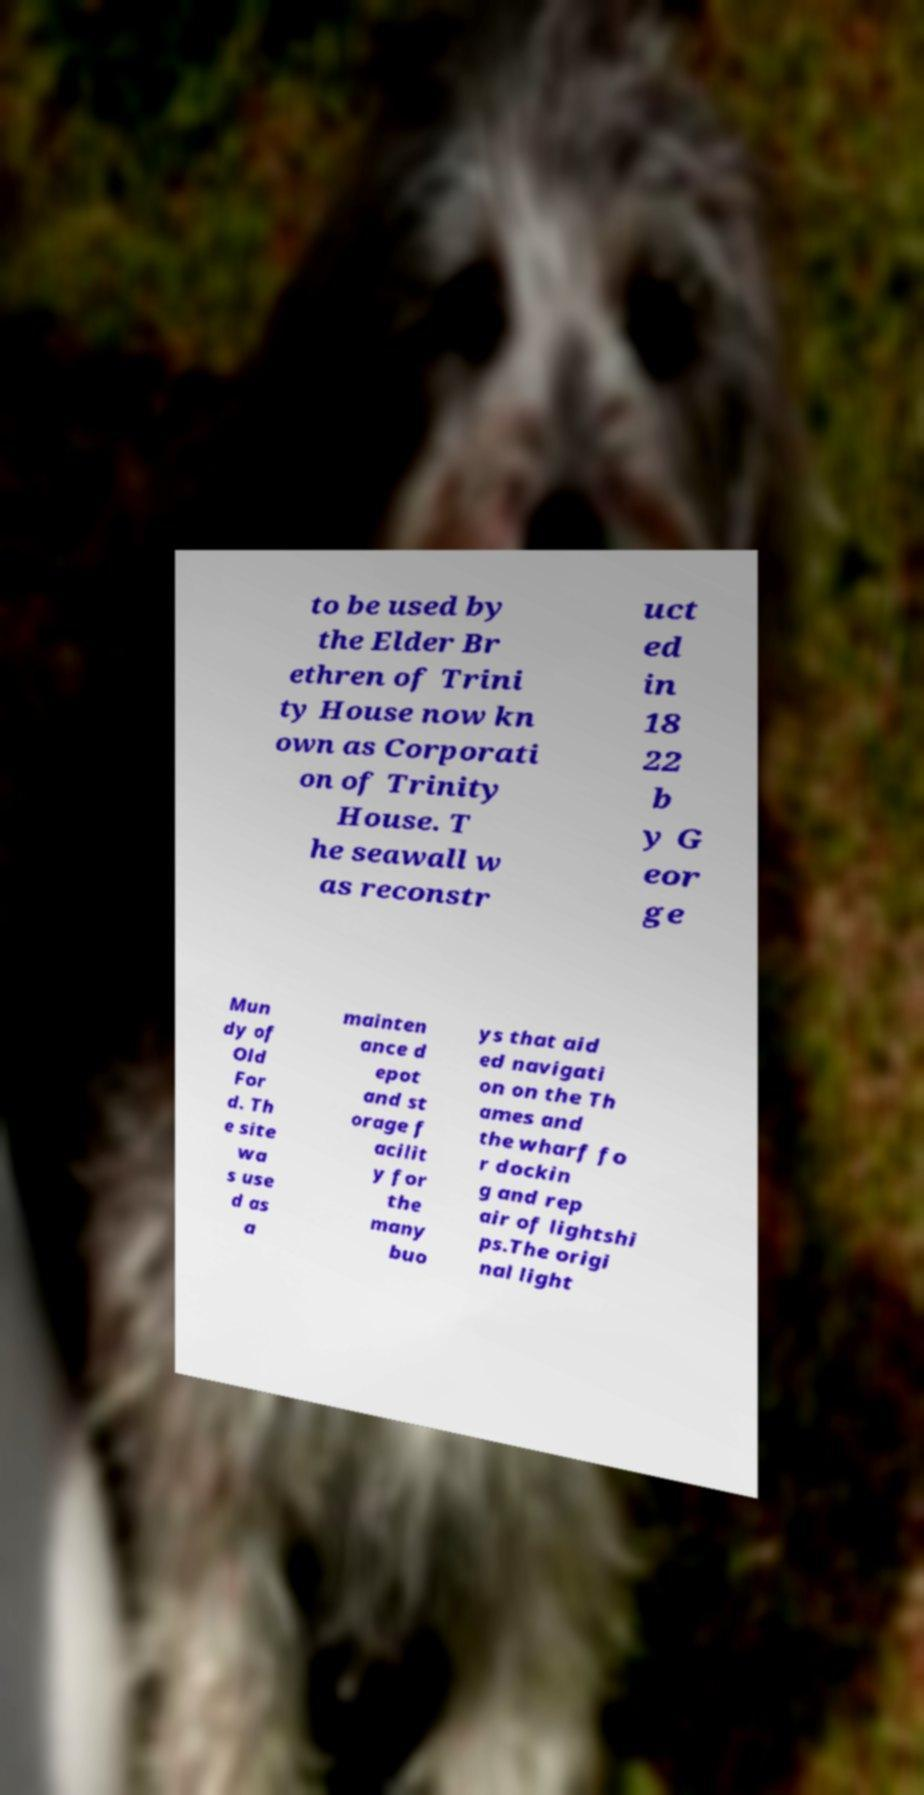For documentation purposes, I need the text within this image transcribed. Could you provide that? to be used by the Elder Br ethren of Trini ty House now kn own as Corporati on of Trinity House. T he seawall w as reconstr uct ed in 18 22 b y G eor ge Mun dy of Old For d. Th e site wa s use d as a mainten ance d epot and st orage f acilit y for the many buo ys that aid ed navigati on on the Th ames and the wharf fo r dockin g and rep air of lightshi ps.The origi nal light 